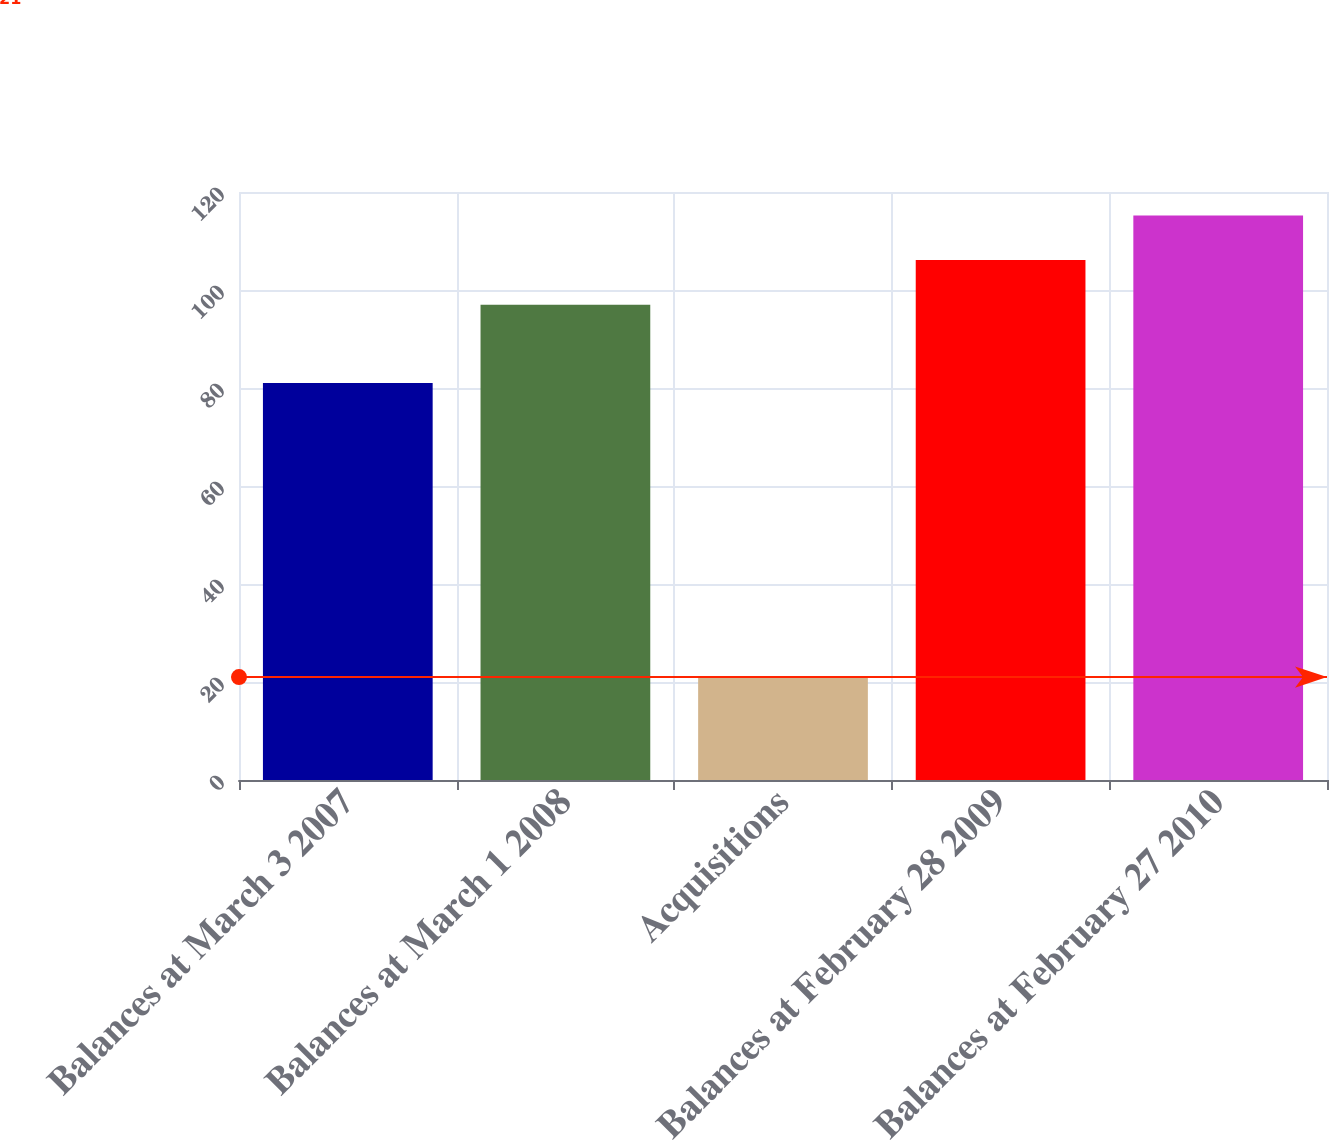Convert chart to OTSL. <chart><loc_0><loc_0><loc_500><loc_500><bar_chart><fcel>Balances at March 3 2007<fcel>Balances at March 1 2008<fcel>Acquisitions<fcel>Balances at February 28 2009<fcel>Balances at February 27 2010<nl><fcel>81<fcel>97<fcel>21<fcel>106.1<fcel>115.2<nl></chart> 